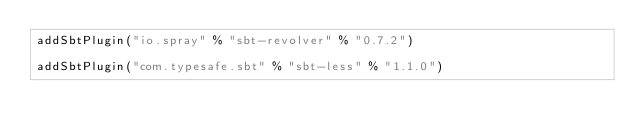Convert code to text. <code><loc_0><loc_0><loc_500><loc_500><_Scala_>addSbtPlugin("io.spray" % "sbt-revolver" % "0.7.2")

addSbtPlugin("com.typesafe.sbt" % "sbt-less" % "1.1.0")
</code> 